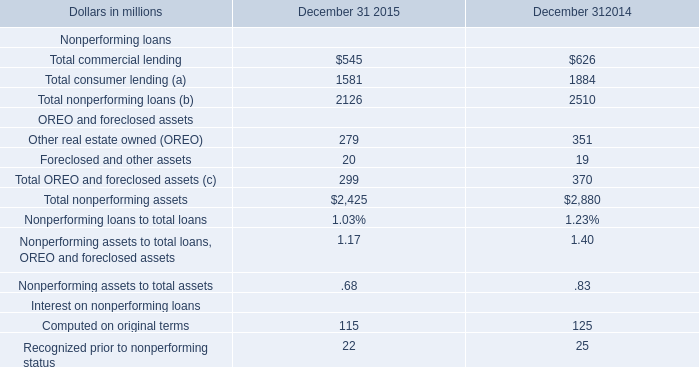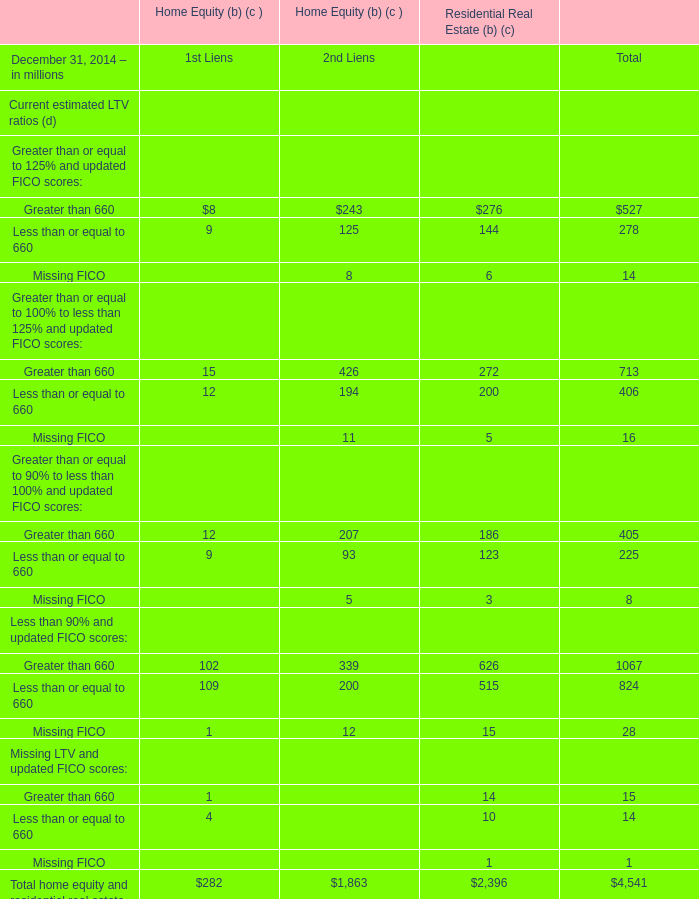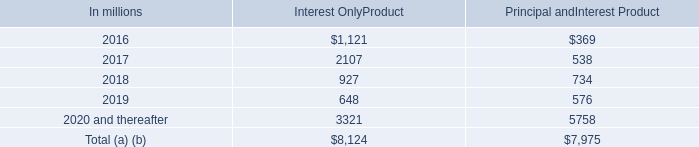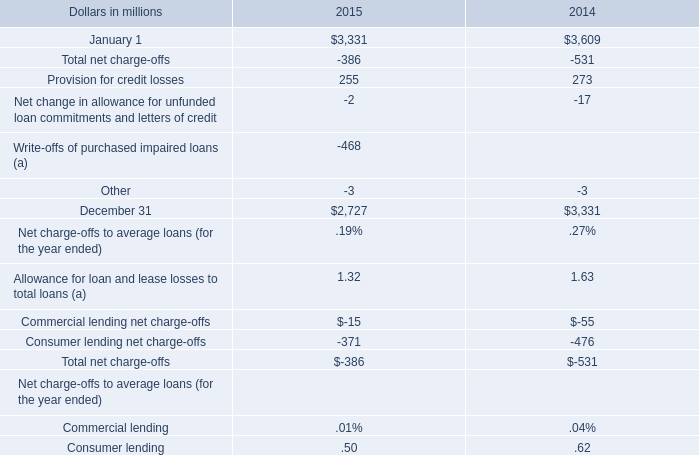How many 1st Liens exceed the average of 1st Liens in 2014? 
Answer: 2. 